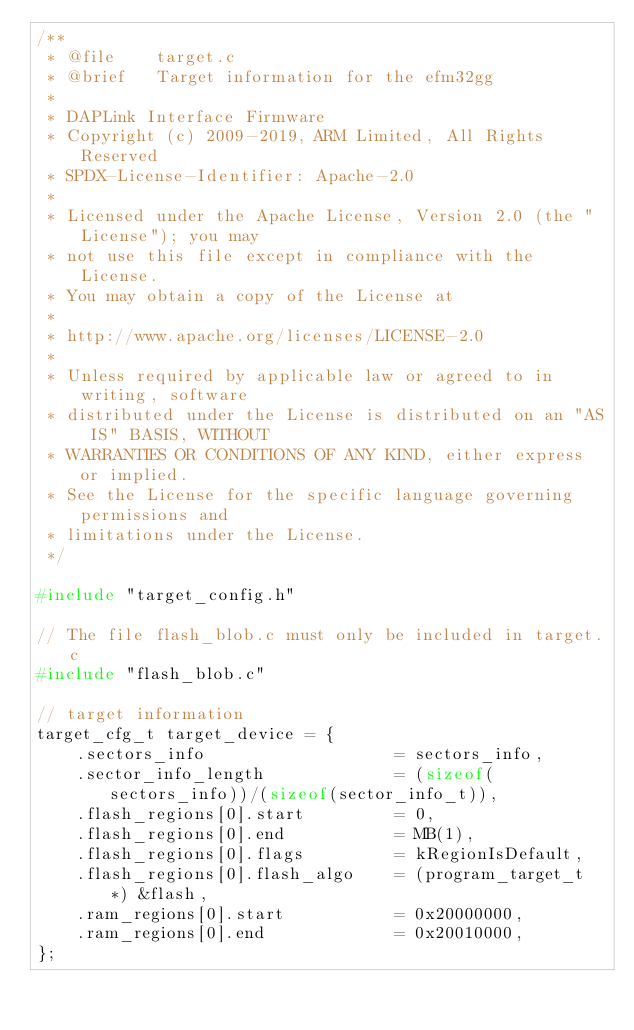Convert code to text. <code><loc_0><loc_0><loc_500><loc_500><_C_>/**
 * @file    target.c
 * @brief   Target information for the efm32gg
 *
 * DAPLink Interface Firmware
 * Copyright (c) 2009-2019, ARM Limited, All Rights Reserved
 * SPDX-License-Identifier: Apache-2.0
 *
 * Licensed under the Apache License, Version 2.0 (the "License"); you may
 * not use this file except in compliance with the License.
 * You may obtain a copy of the License at
 *
 * http://www.apache.org/licenses/LICENSE-2.0
 *
 * Unless required by applicable law or agreed to in writing, software
 * distributed under the License is distributed on an "AS IS" BASIS, WITHOUT
 * WARRANTIES OR CONDITIONS OF ANY KIND, either express or implied.
 * See the License for the specific language governing permissions and
 * limitations under the License.
 */

#include "target_config.h"

// The file flash_blob.c must only be included in target.c
#include "flash_blob.c"

// target information
target_cfg_t target_device = {
    .sectors_info                   = sectors_info,
    .sector_info_length             = (sizeof(sectors_info))/(sizeof(sector_info_t)),
    .flash_regions[0].start         = 0,
    .flash_regions[0].end           = MB(1),
    .flash_regions[0].flags         = kRegionIsDefault,
    .flash_regions[0].flash_algo    = (program_target_t *) &flash,    
    .ram_regions[0].start           = 0x20000000,
    .ram_regions[0].end             = 0x20010000,
};
</code> 